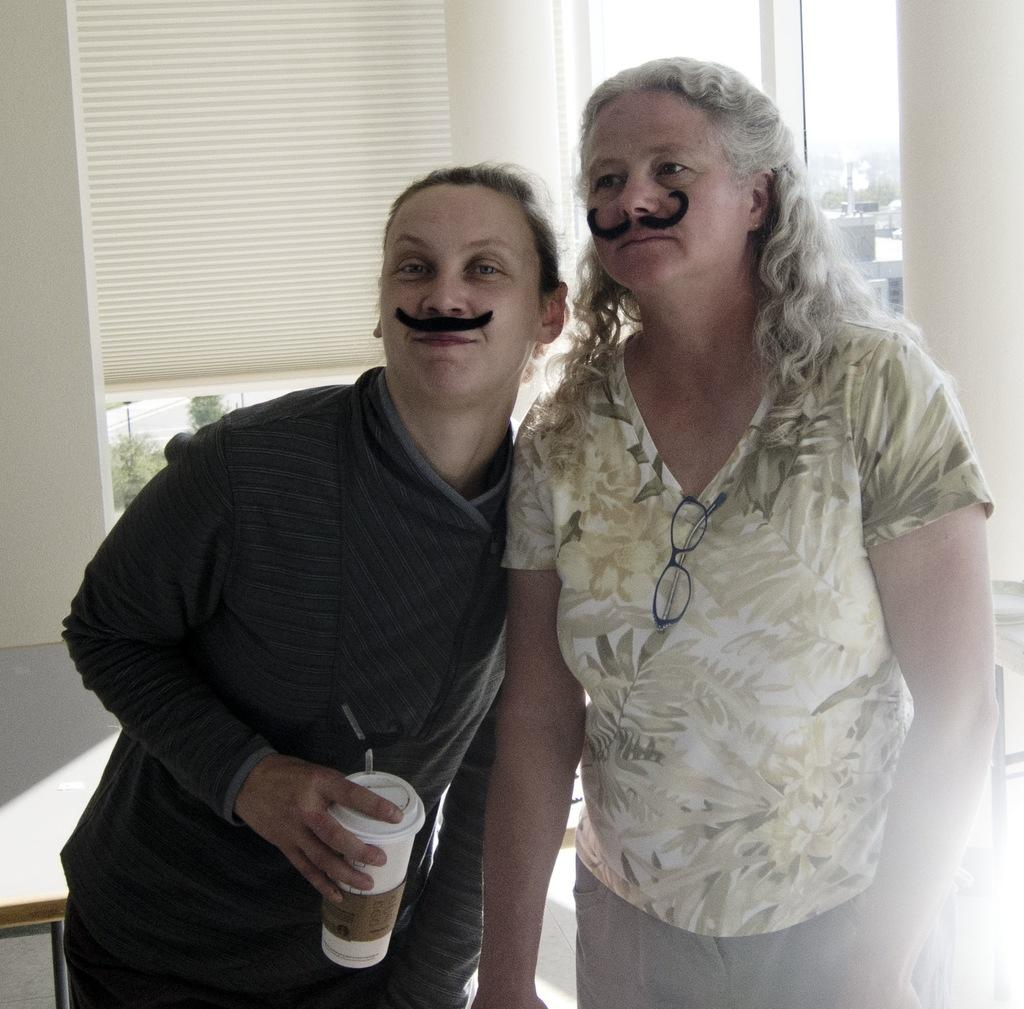How many women are in the image? There are two women standing in the image. What is one of the women holding? One of the women is holding a tin with a straw. What can be seen in the background of the image? There is a table, window blinds, trees, buildings, and the sky visible in the background of the image. What type of cheese is being grated by the bee in the image? There is no bee or cheese present in the image. Is there a fire visible in the image? No, there is no fire visible in the image. 